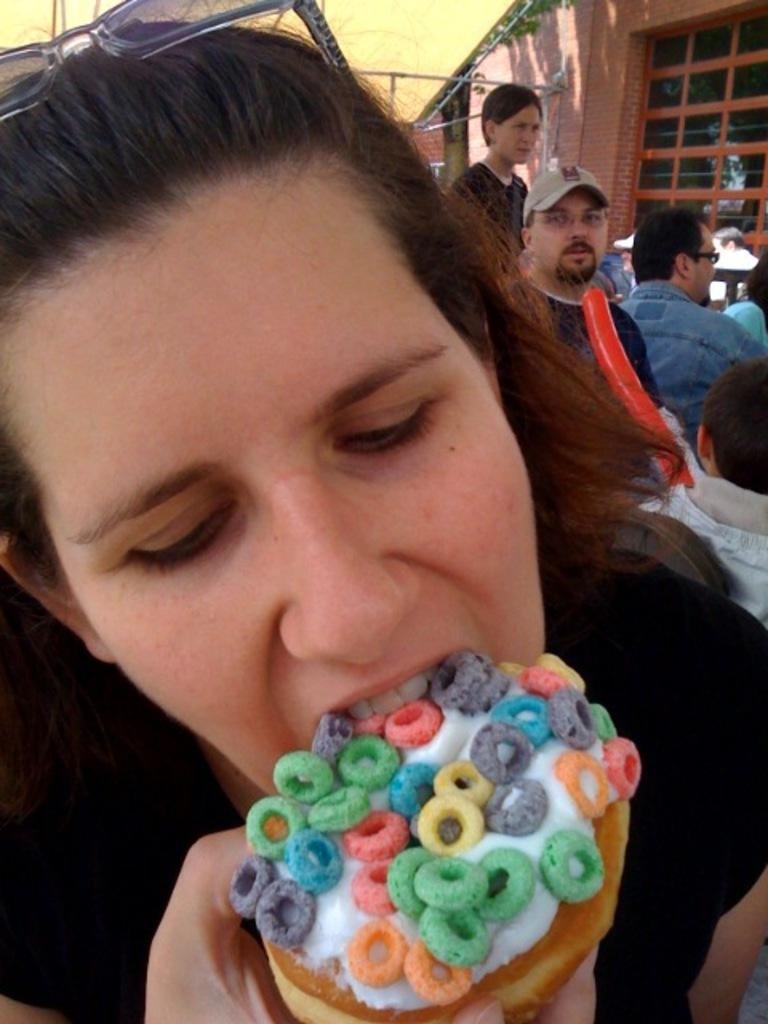Who is the main subject in the image? There is a person in the image. What is the person doing in the image? The person is eating ice cream. Can you describe the surroundings in the image? There are people visible in the background of the image, and there is a building in the background as well. What type of tax is being discussed by the person eating ice cream in the image? There is no indication in the image that the person is discussing any type of tax. 